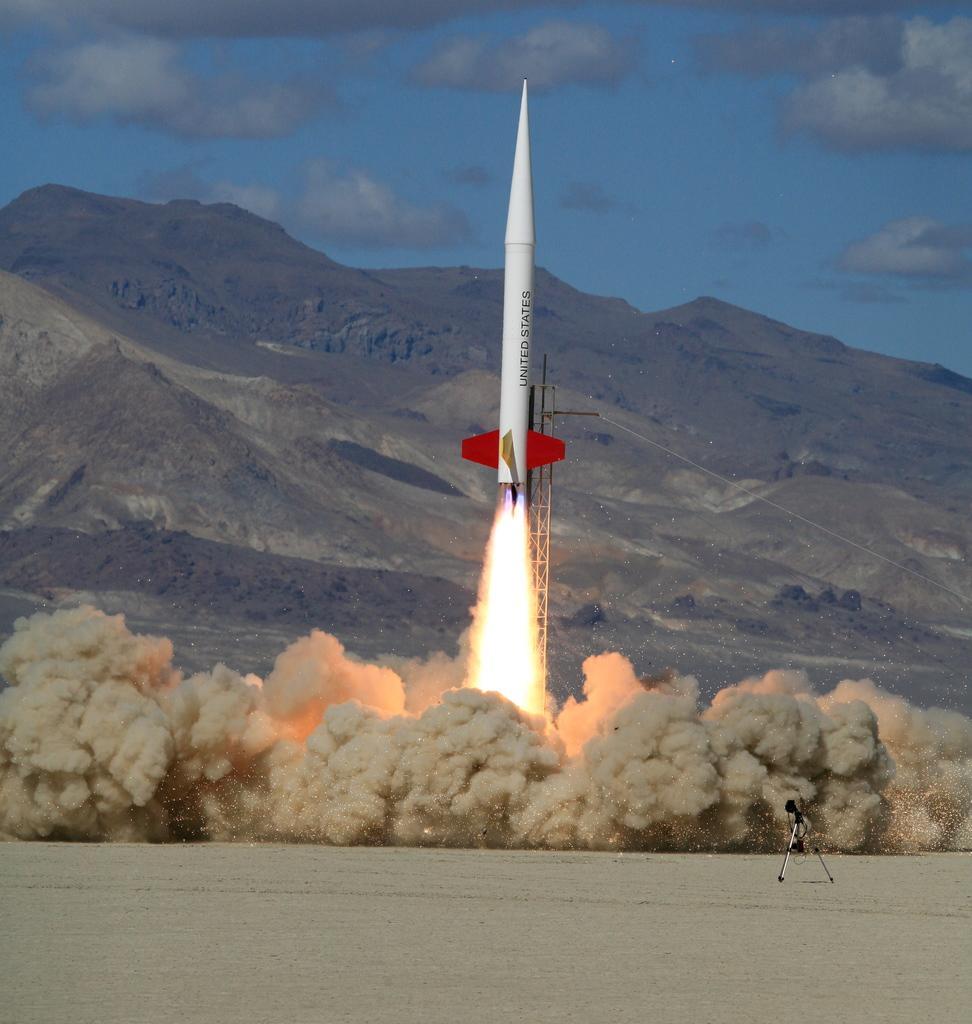What country is this rocket from?
Your answer should be compact. United states. 